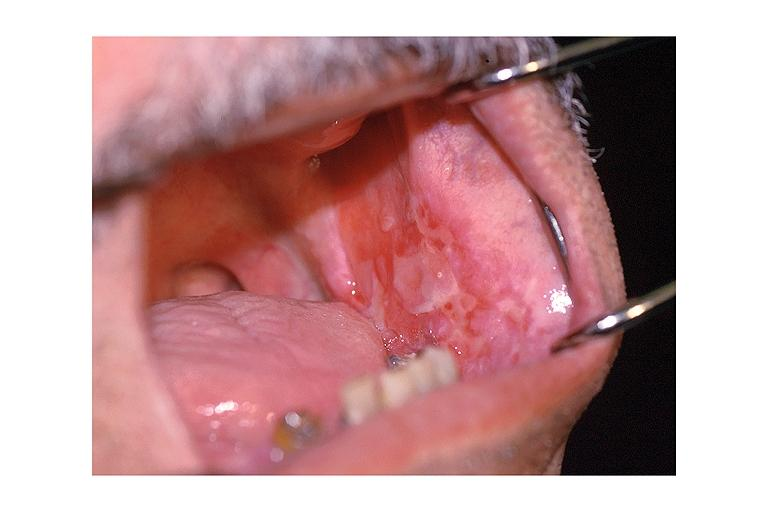s acute monocytic leukemia present?
Answer the question using a single word or phrase. No 